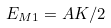<formula> <loc_0><loc_0><loc_500><loc_500>E _ { M 1 } = A K / 2</formula> 